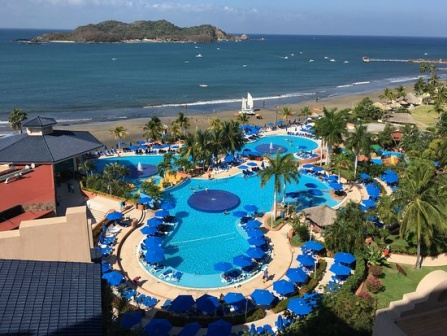Explain the visual content of the image in great detail. The image provides a stunning aerial view of a lush, coastal resort. The centerpiece of the resort is an elaborate, bright blue swimming pool, designed with a whimsical flower-like shape that includes several winding petals and recesses. Scattered around the pool are numerous blue lounge chairs topped with matching blue umbrellas, exuding an inviting and relaxing atmosphere for sunbathers and swimmers alike.

The architecture of the resort adds to its charm, with its buildings painted in a soothing peach-pink hue and capped with contrasting red and blue rooftops. These structures surround the pool area, providing easy access for guests to the resort’s main attraction.

Looking beyond the resort's premises, the golden sandy beach extends towards a rich blue ocean, interspersed with a few small boats hinting at various water-based activities. The horizon reveals a small, verdant island that adds an air of adventure and intrigue to the scene. Above all this, the sky is a clear blue with soft, sparse clouds, heightening the serene and tranquil feeling of the vacation spot. 